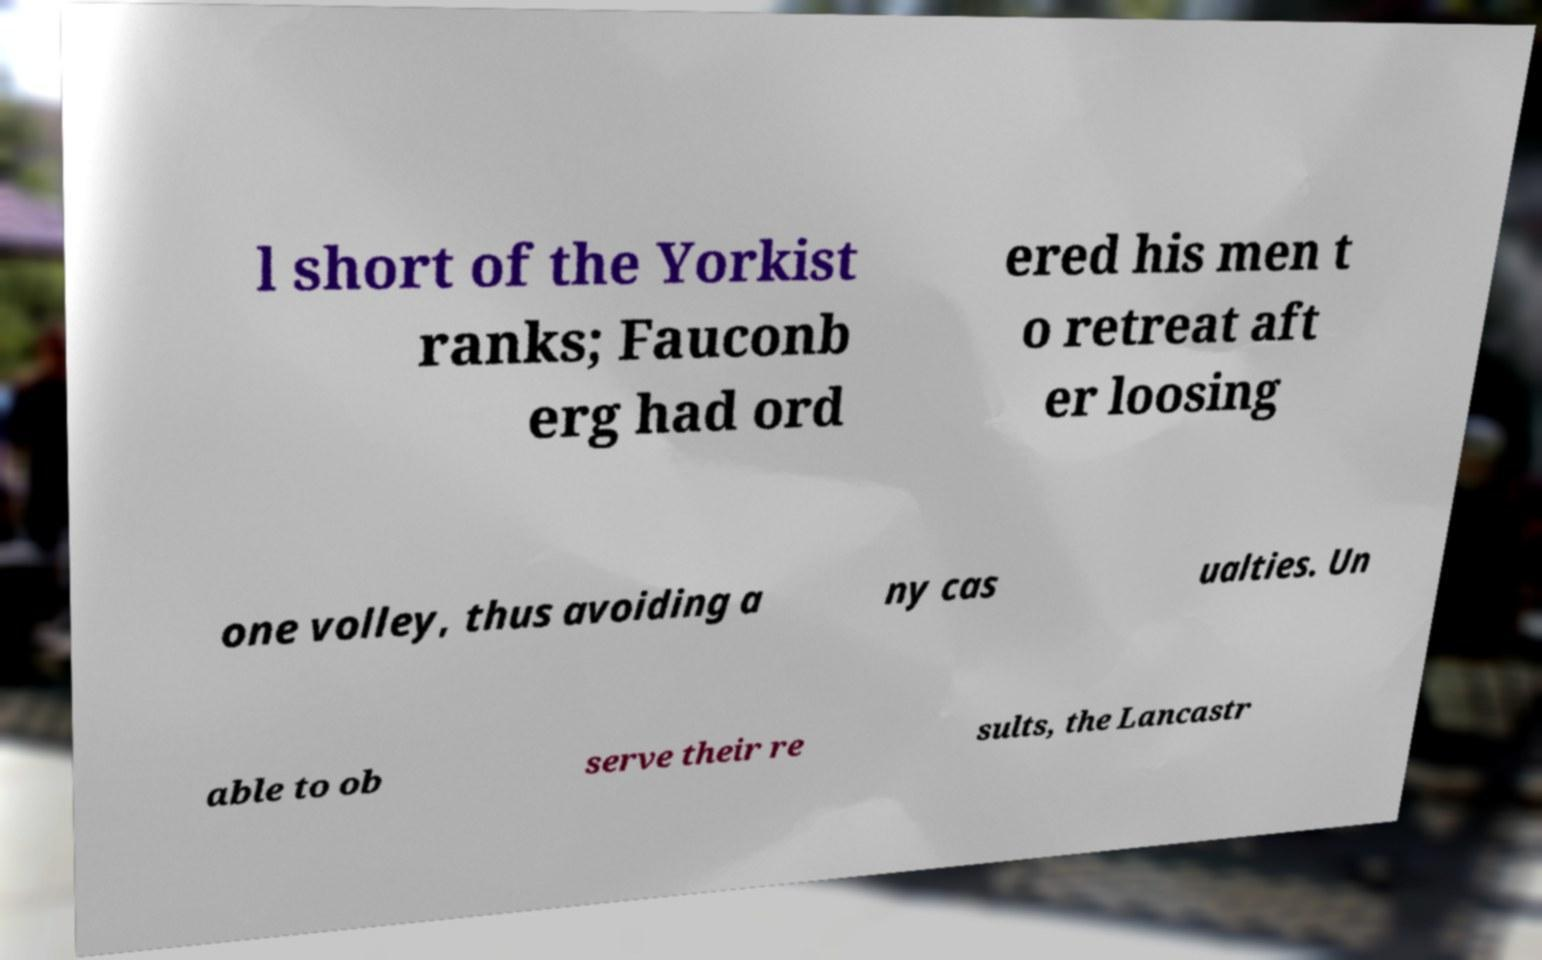Please read and relay the text visible in this image. What does it say? l short of the Yorkist ranks; Fauconb erg had ord ered his men t o retreat aft er loosing one volley, thus avoiding a ny cas ualties. Un able to ob serve their re sults, the Lancastr 